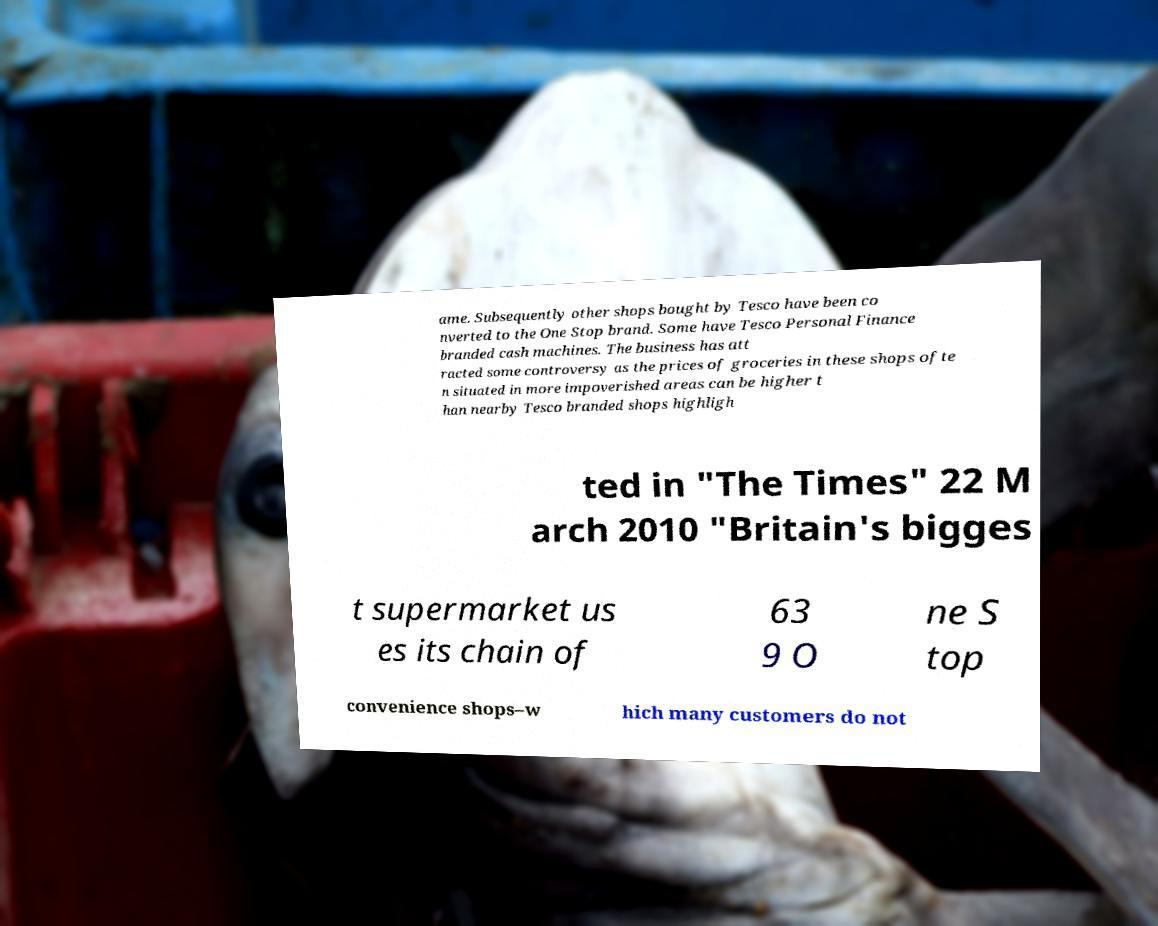Please identify and transcribe the text found in this image. ame. Subsequently other shops bought by Tesco have been co nverted to the One Stop brand. Some have Tesco Personal Finance branded cash machines. The business has att racted some controversy as the prices of groceries in these shops ofte n situated in more impoverished areas can be higher t han nearby Tesco branded shops highligh ted in "The Times" 22 M arch 2010 "Britain's bigges t supermarket us es its chain of 63 9 O ne S top convenience shops–w hich many customers do not 